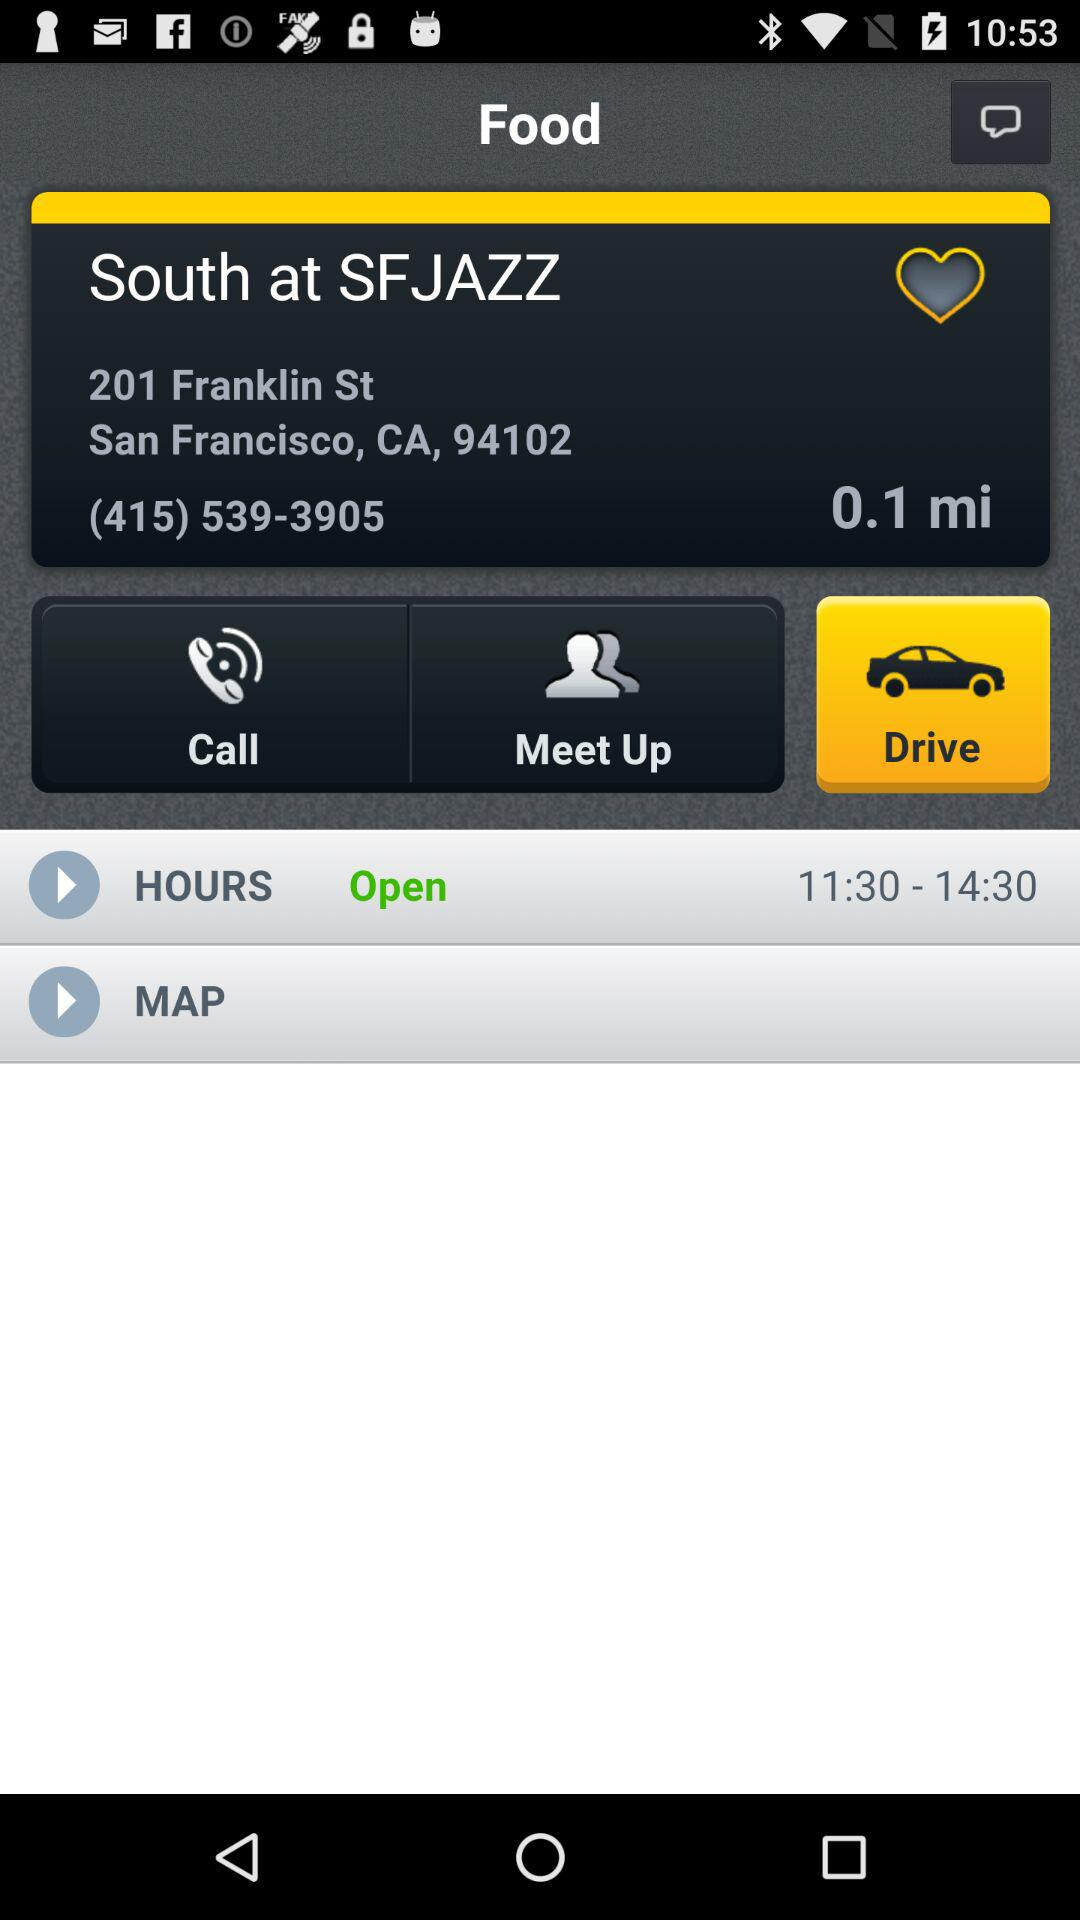What are the open timings? The open timings are 11:30–14:30. 